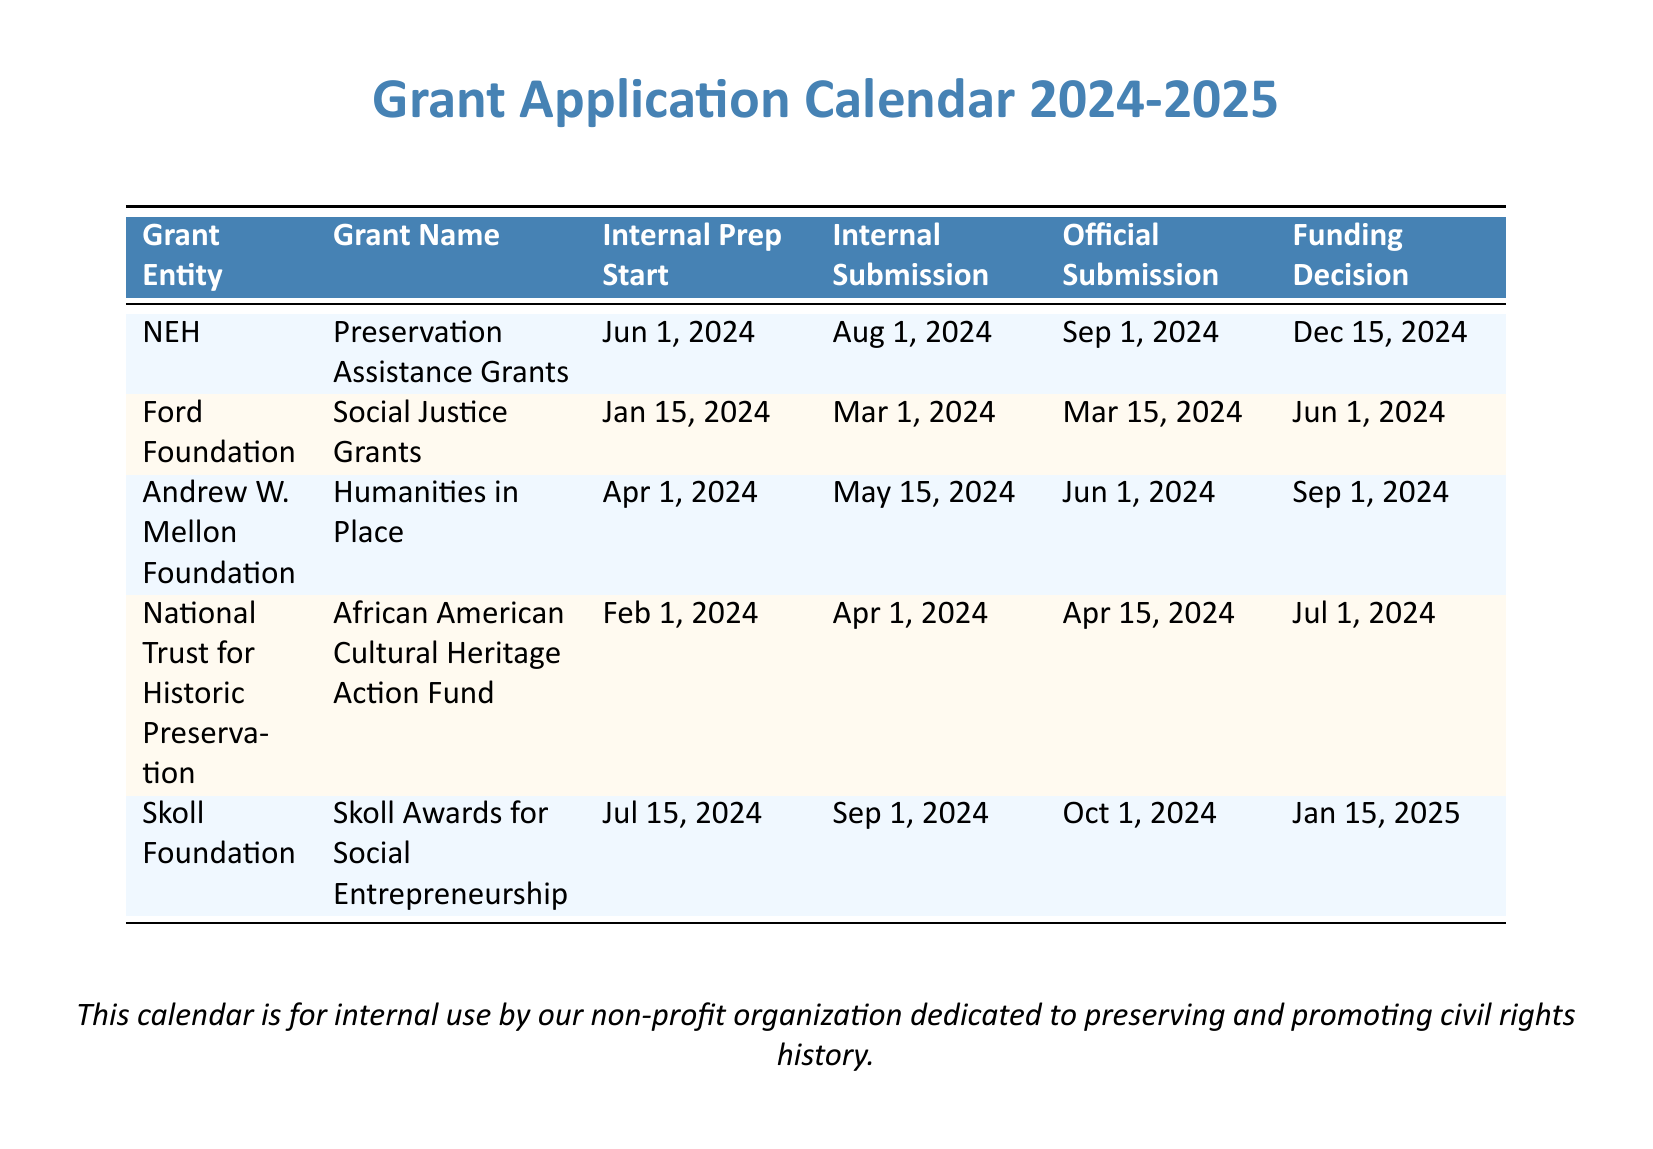What is the grant name from the NEH? The NEH grant name listed in the document is "Preservation Assistance Grants."
Answer: Preservation Assistance Grants When is the official submission date for the Ford Foundation grant? The official submission date for the Ford Foundation grant, "Social Justice Grants," is given as March 15, 2024.
Answer: Mar 15, 2024 What is the funding decision date for the Andrew W. Mellon Foundation's Humanities in Place grant? The funding decision date is the final date in the row for this grant, which is September 1, 2024.
Answer: Sep 1, 2024 Which grant has the latest internal submission date? Comparing the internal submission dates, the Skoll Foundation has the latest internal submission date of September 1, 2024.
Answer: Sep 1, 2024 What is the internal prep start date for the National Trust for Historic Preservation's grant? The internal prep start date for this grant, "African American Cultural Heritage Action Fund," is February 1, 2024.
Answer: Feb 1, 2024 Which foundation has a grant decision due on January 15, 2025? The Skoll Foundation is the only entity with a funding decision due on this date.
Answer: Skoll Foundation How many grants require internal preparation to start by June 1, 2024? Two grants require internal preparation to start by June 1, 2024, which are from NEH and Andrew W. Mellon Foundation.
Answer: 2 What color is used for the header in this document? The header color defined in the document is provided as "headercolor" with the specific RGB values.
Answer: headercolor What does this calendar document serve as? According to the document, it is for internal use by the non-profit organization.
Answer: Internal use 